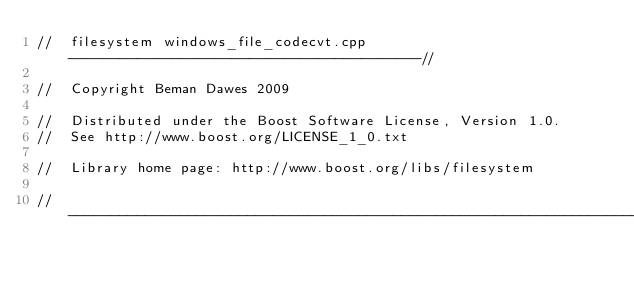<code> <loc_0><loc_0><loc_500><loc_500><_C++_>//  filesystem windows_file_codecvt.cpp  -----------------------------------------//

//  Copyright Beman Dawes 2009

//  Distributed under the Boost Software License, Version 1.0.
//  See http://www.boost.org/LICENSE_1_0.txt

//  Library home page: http://www.boost.org/libs/filesystem

//--------------------------------------------------------------------------------------//
</code> 